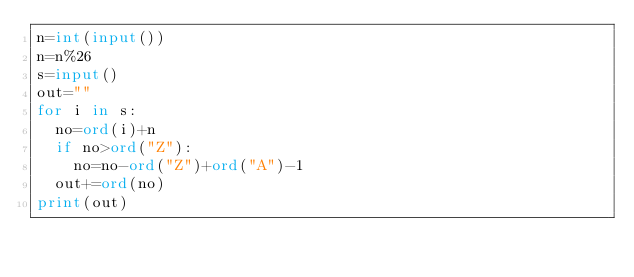Convert code to text. <code><loc_0><loc_0><loc_500><loc_500><_Python_>n=int(input())
n=n%26
s=input()
out=""
for i in s:
  no=ord(i)+n
  if no>ord("Z"):
    no=no-ord("Z")+ord("A")-1
  out+=ord(no)
print(out)
  </code> 